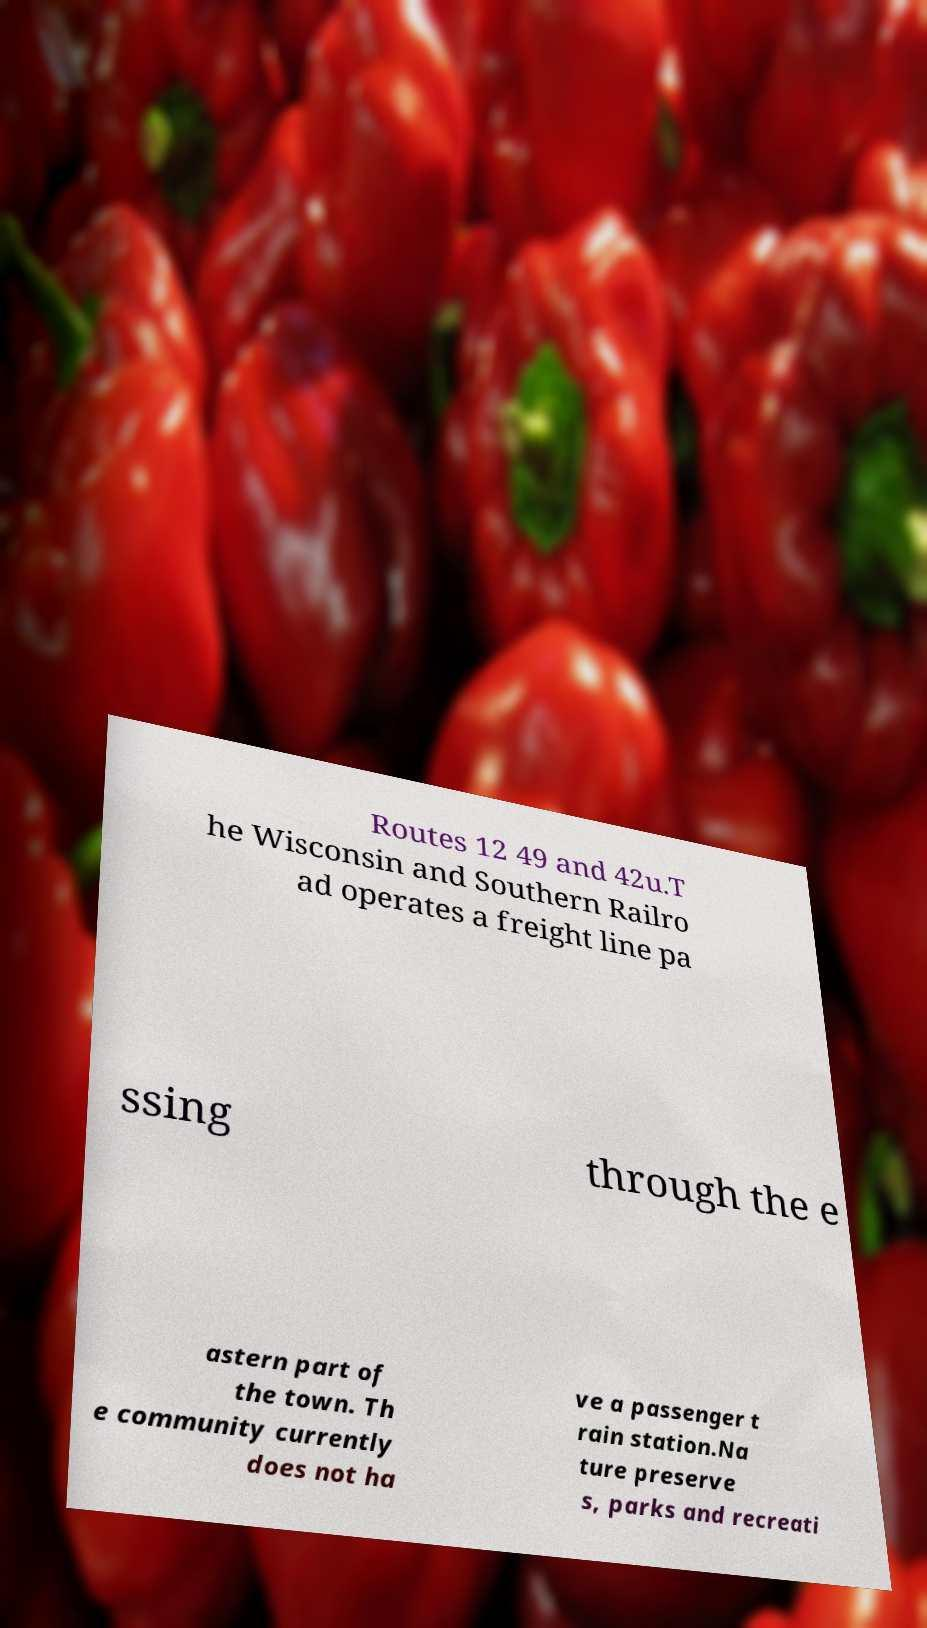Please identify and transcribe the text found in this image. Routes 12 49 and 42u.T he Wisconsin and Southern Railro ad operates a freight line pa ssing through the e astern part of the town. Th e community currently does not ha ve a passenger t rain station.Na ture preserve s, parks and recreati 